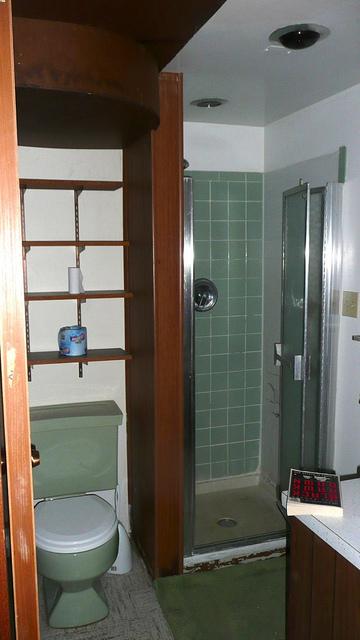How many rolls of toilet paper are on the shelves above the toilet?
Write a very short answer. 2. What is on the sink counter?
Keep it brief. Book. Is that a heat lamp on the ceiling?
Short answer required. Yes. 